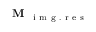<formula> <loc_0><loc_0><loc_500><loc_500>M _ { i m g . r e s }</formula> 